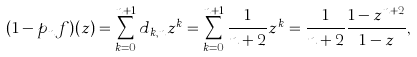<formula> <loc_0><loc_0><loc_500><loc_500>( 1 - p _ { n } f ) ( z ) = \sum _ { k = 0 } ^ { n + 1 } d _ { k , n } z ^ { k } = \sum _ { k = 0 } ^ { n + 1 } \frac { 1 } { n + 2 } z ^ { k } = \frac { 1 } { n + 2 } \frac { 1 - z ^ { n + 2 } } { 1 - z } ,</formula> 